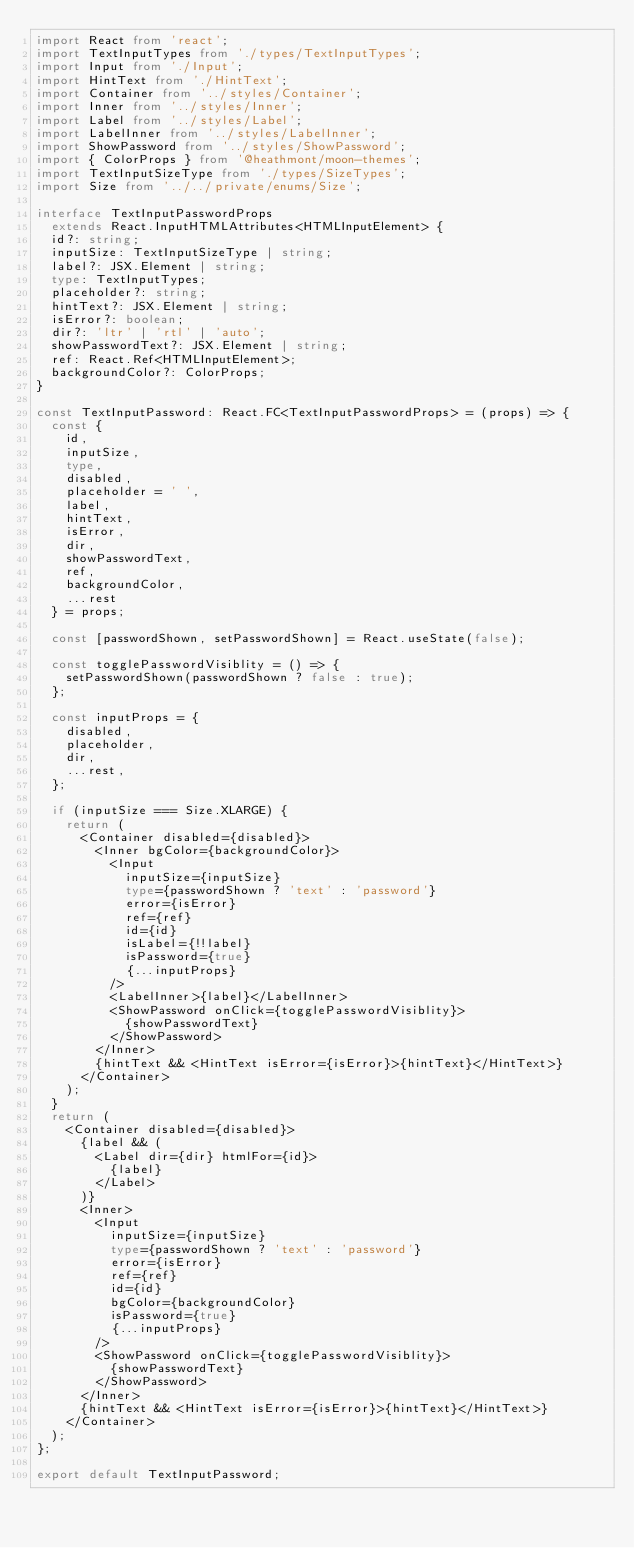Convert code to text. <code><loc_0><loc_0><loc_500><loc_500><_TypeScript_>import React from 'react';
import TextInputTypes from './types/TextInputTypes';
import Input from './Input';
import HintText from './HintText';
import Container from '../styles/Container';
import Inner from '../styles/Inner';
import Label from '../styles/Label';
import LabelInner from '../styles/LabelInner';
import ShowPassword from '../styles/ShowPassword';
import { ColorProps } from '@heathmont/moon-themes';
import TextInputSizeType from './types/SizeTypes';
import Size from '../../private/enums/Size';

interface TextInputPasswordProps
  extends React.InputHTMLAttributes<HTMLInputElement> {
  id?: string;
  inputSize: TextInputSizeType | string;
  label?: JSX.Element | string;
  type: TextInputTypes;
  placeholder?: string;
  hintText?: JSX.Element | string;
  isError?: boolean;
  dir?: 'ltr' | 'rtl' | 'auto';
  showPasswordText?: JSX.Element | string;
  ref: React.Ref<HTMLInputElement>;
  backgroundColor?: ColorProps;
}

const TextInputPassword: React.FC<TextInputPasswordProps> = (props) => {
  const {
    id,
    inputSize,
    type,
    disabled,
    placeholder = ' ',
    label,
    hintText,
    isError,
    dir,
    showPasswordText,
    ref,
    backgroundColor,
    ...rest
  } = props;

  const [passwordShown, setPasswordShown] = React.useState(false);

  const togglePasswordVisiblity = () => {
    setPasswordShown(passwordShown ? false : true);
  };

  const inputProps = {
    disabled,
    placeholder,
    dir,
    ...rest,
  };

  if (inputSize === Size.XLARGE) {
    return (
      <Container disabled={disabled}>
        <Inner bgColor={backgroundColor}>
          <Input
            inputSize={inputSize}
            type={passwordShown ? 'text' : 'password'}
            error={isError}
            ref={ref}
            id={id}
            isLabel={!!label}
            isPassword={true}
            {...inputProps}
          />
          <LabelInner>{label}</LabelInner>
          <ShowPassword onClick={togglePasswordVisiblity}>
            {showPasswordText}
          </ShowPassword>
        </Inner>
        {hintText && <HintText isError={isError}>{hintText}</HintText>}
      </Container>
    );
  }
  return (
    <Container disabled={disabled}>
      {label && (
        <Label dir={dir} htmlFor={id}>
          {label}
        </Label>
      )}
      <Inner>
        <Input
          inputSize={inputSize}
          type={passwordShown ? 'text' : 'password'}
          error={isError}
          ref={ref}
          id={id}
          bgColor={backgroundColor}
          isPassword={true}
          {...inputProps}
        />
        <ShowPassword onClick={togglePasswordVisiblity}>
          {showPasswordText}
        </ShowPassword>
      </Inner>
      {hintText && <HintText isError={isError}>{hintText}</HintText>}
    </Container>
  );
};

export default TextInputPassword;
</code> 